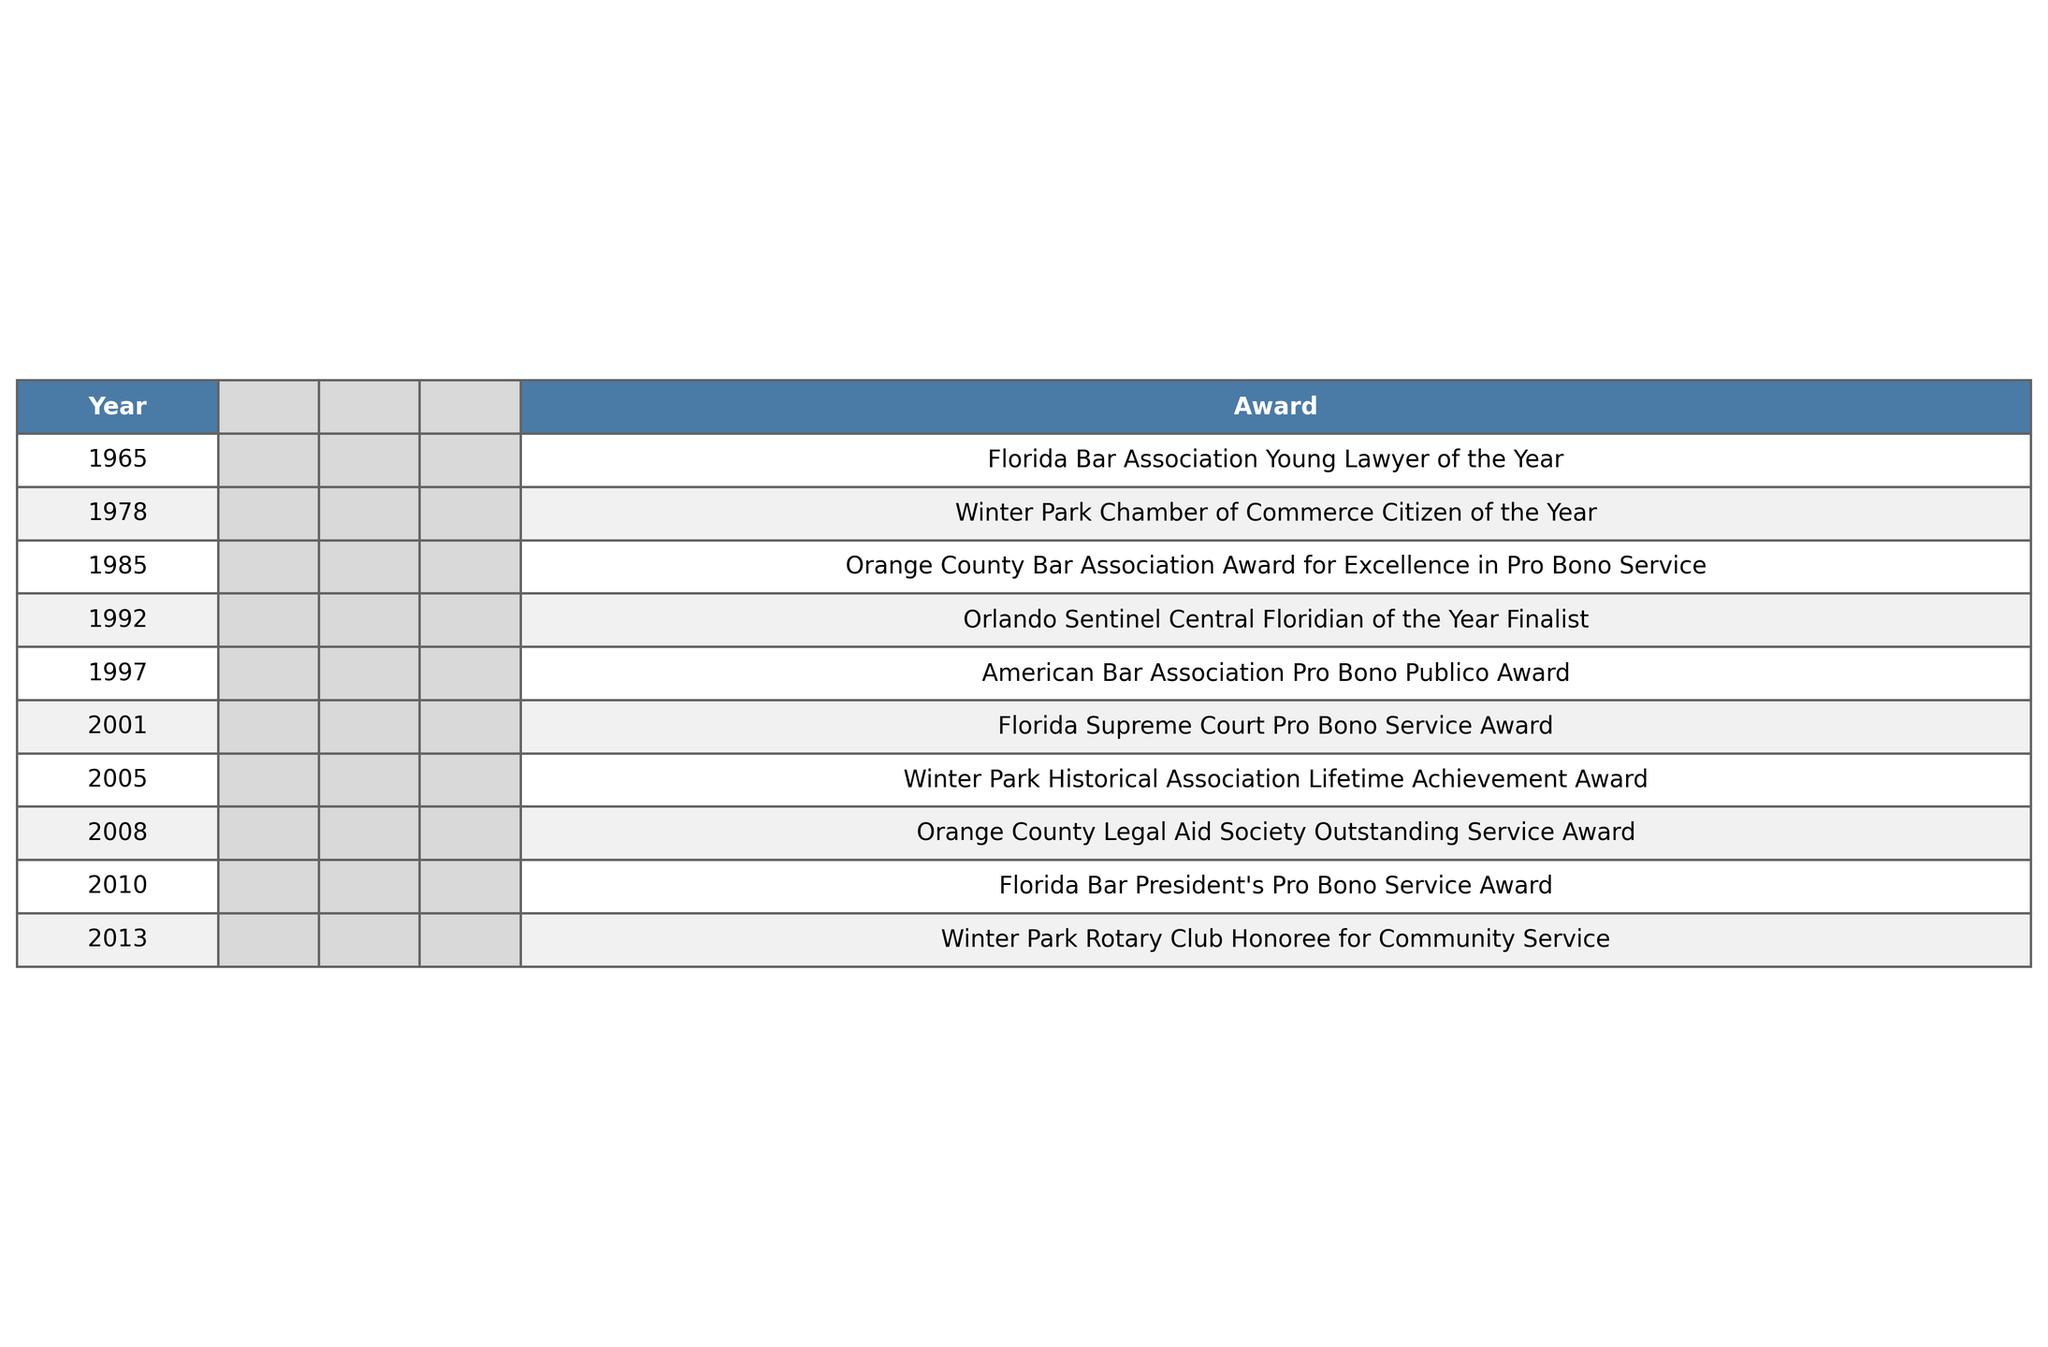What award did Kenneth F. Murrah receive in 1985? The table indicates that in 1985, he received the Orange County Bar Association Award for Excellence in Pro Bono Service.
Answer: Orange County Bar Association Award for Excellence in Pro Bono Service How many awards did Kenneth F. Murrah receive in the 2000s? Reviewing the table, there are five awards listed between the years 2000 and 2009, inclusive: Florida Supreme Court Pro Bono Service Award (2001), Winter Park Historical Association Lifetime Achievement Award (2005), and Florida Bar President's Pro Bono Service Award (2010). However, the count only includes awards before 2010, thus totaling four.
Answer: Four True or False: Kenneth F. Murrah was a finalist for the Orlando Sentinel Central Floridian of the Year award. The table shows that he was listed as a finalist for the Orlando Sentinel Central Floridian of the Year in 1992, confirming the statement is true.
Answer: True What is the most recent award Kenneth F. Murrah received according to the table? The last entry in the table lists the Florida Bar President's Pro Bono Service Award as the most recent award given in 2010.
Answer: Florida Bar President's Pro Bono Service Award How many years passed between Kenneth F. Murrah's first and last awards listed in the table? The first award was received in 1965, and the last award was received in 2010. To find the difference, subtract 1965 from 2010, which gives 45 years.
Answer: 45 years What year saw the highest number of awards received by Kenneth F. Murrah at once? Reviewing the table, each year only lists one award; therefore, no year had more than one award. Every time he received an award, it was in a separate year.
Answer: Every year had one award In which decade did Kenneth F. Murrah receive the most awards? Counting the awards listed in each decade: 1960s (1), 1970s (2), 1980s (1), 1990s (2), 2000s (4), and 2010s (1). The 2000s have the highest total with four awards.
Answer: 2000s Which awards were related to community service? The following awards from the table are explicitly related to community service: Winter Park Chamber of Commerce Citizen of the Year (1978), American Bar Association Pro Bono Publico Award (1997), Florida Supreme Court Pro Bono Service Award (2001), and Florida Bar President's Pro Bono Service Award (2010).
Answer: Four awards related to community service Was there a time when Kenneth F. Murrah was recognized by both a bar association and a historical association? According to the table, Kenneth F. Murrah received awards from the Orange County Bar Association (1985) and the Winter Park Historical Association (2005), confirming that he was recognized by both associations at different times.
Answer: Yes 